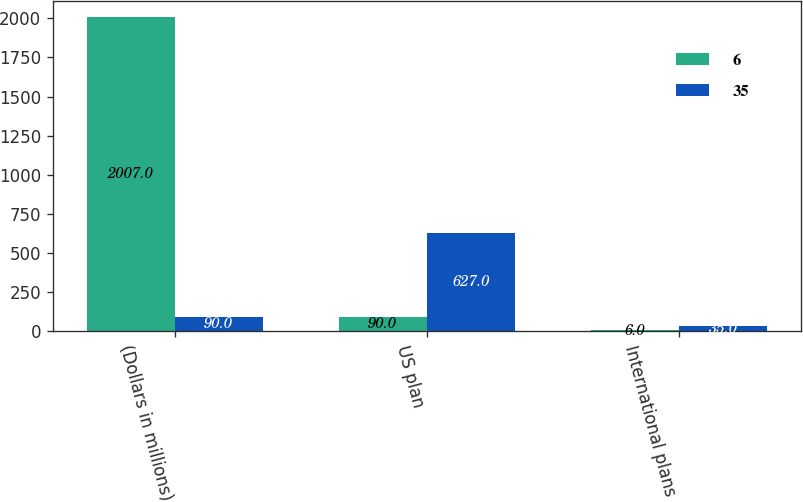Convert chart to OTSL. <chart><loc_0><loc_0><loc_500><loc_500><stacked_bar_chart><ecel><fcel>(Dollars in millions)<fcel>US plan<fcel>International plans<nl><fcel>6<fcel>2007<fcel>90<fcel>6<nl><fcel>35<fcel>90<fcel>627<fcel>35<nl></chart> 